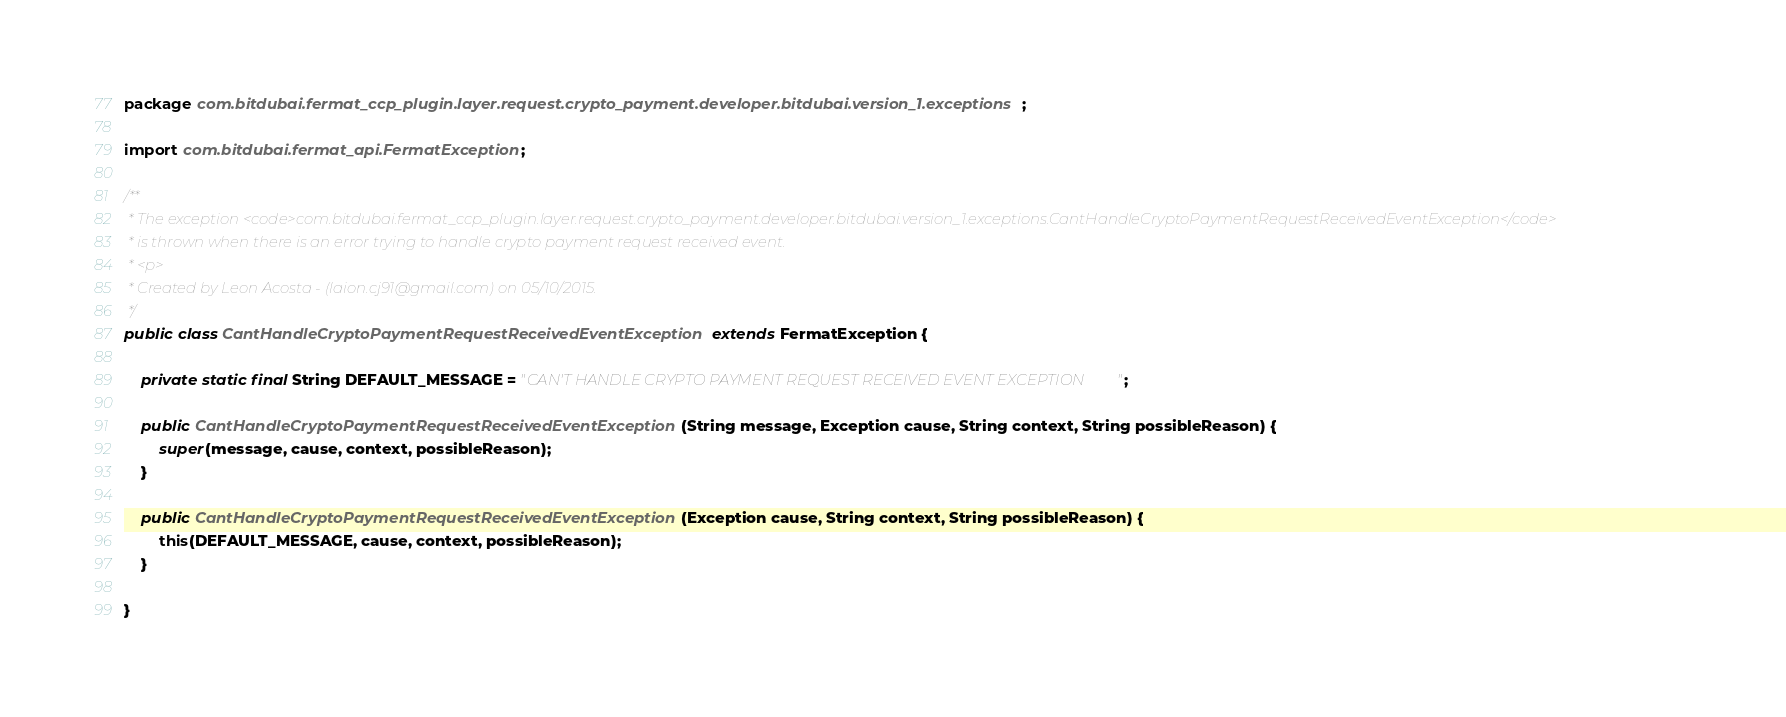<code> <loc_0><loc_0><loc_500><loc_500><_Java_>package com.bitdubai.fermat_ccp_plugin.layer.request.crypto_payment.developer.bitdubai.version_1.exceptions;

import com.bitdubai.fermat_api.FermatException;

/**
 * The exception <code>com.bitdubai.fermat_ccp_plugin.layer.request.crypto_payment.developer.bitdubai.version_1.exceptions.CantHandleCryptoPaymentRequestReceivedEventException</code>
 * is thrown when there is an error trying to handle crypto payment request received event.
 * <p>
 * Created by Leon Acosta - (laion.cj91@gmail.com) on 05/10/2015.
 */
public class CantHandleCryptoPaymentRequestReceivedEventException extends FermatException {

    private static final String DEFAULT_MESSAGE = "CAN'T HANDLE CRYPTO PAYMENT REQUEST RECEIVED EVENT EXCEPTION";

    public CantHandleCryptoPaymentRequestReceivedEventException(String message, Exception cause, String context, String possibleReason) {
        super(message, cause, context, possibleReason);
    }

    public CantHandleCryptoPaymentRequestReceivedEventException(Exception cause, String context, String possibleReason) {
        this(DEFAULT_MESSAGE, cause, context, possibleReason);
    }

}
</code> 